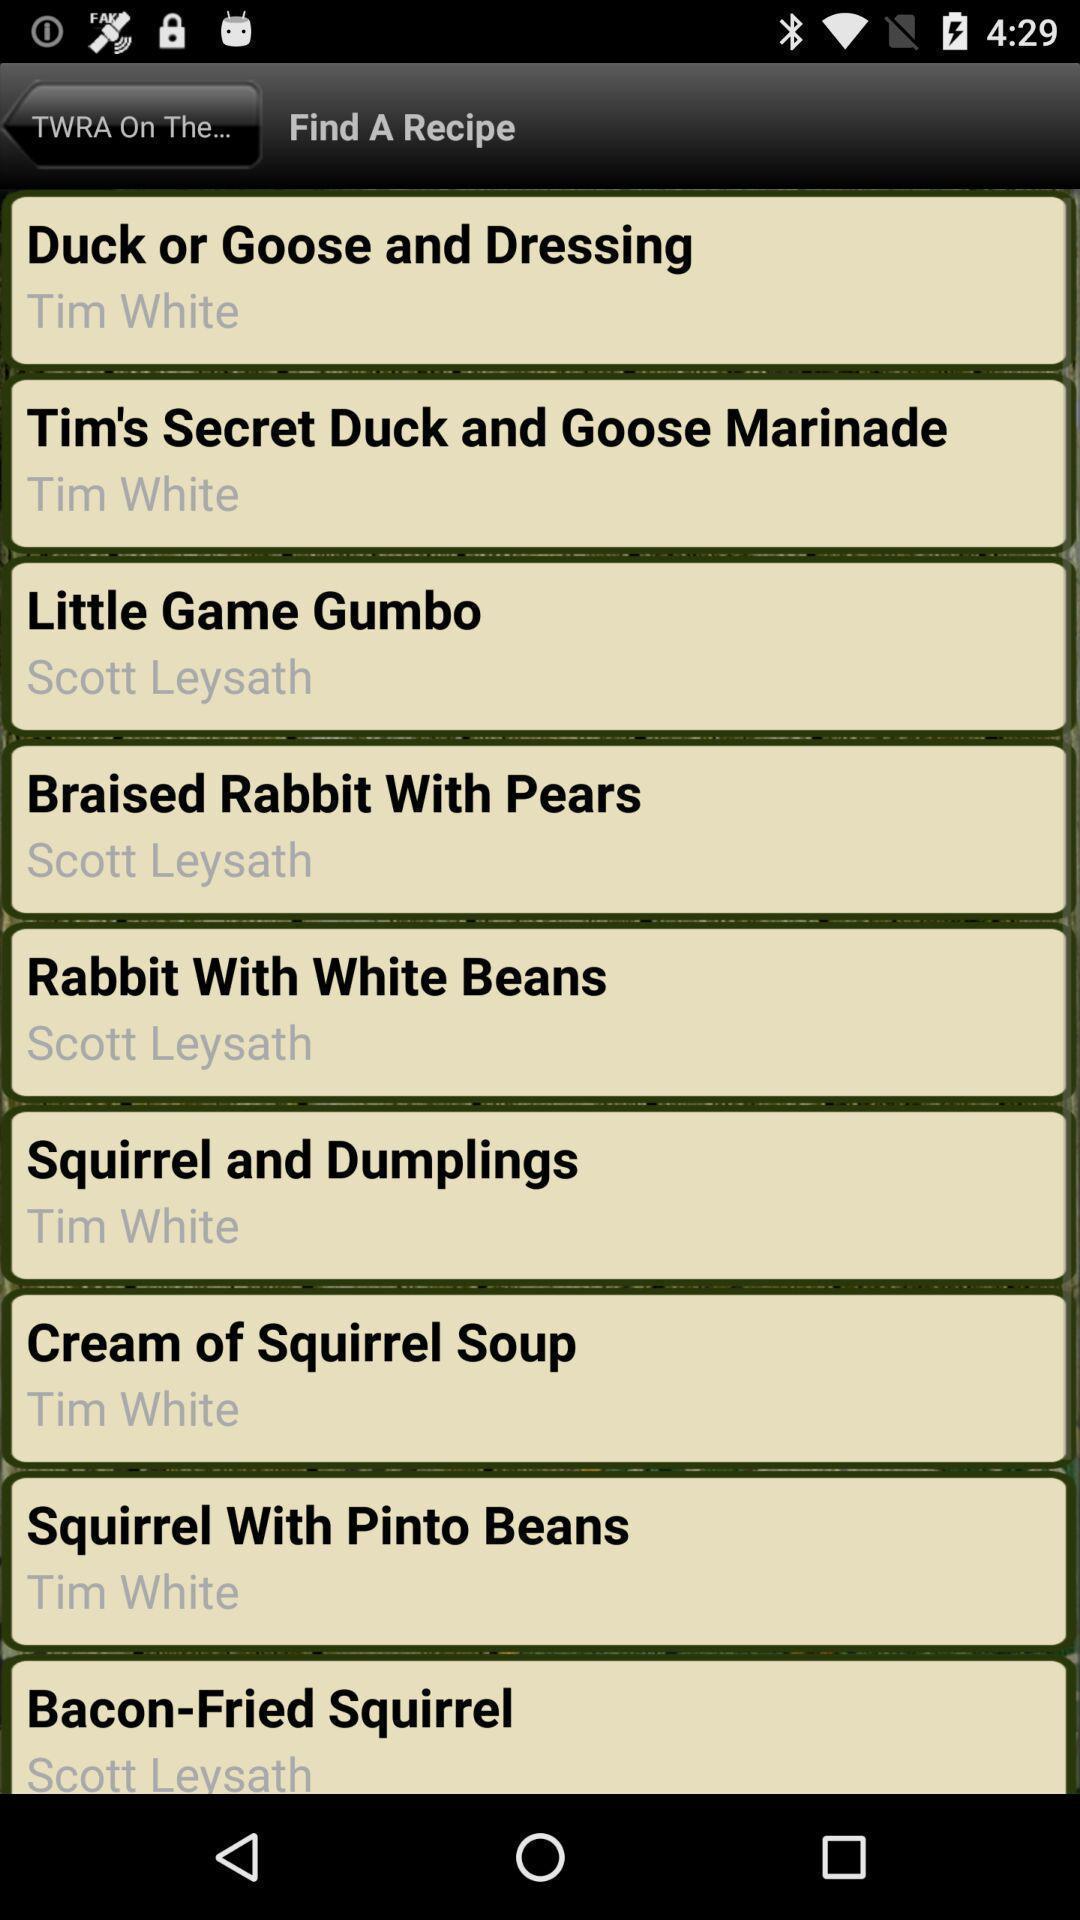Explain the elements present in this screenshot. Various recipes displayed on a cooking app. 